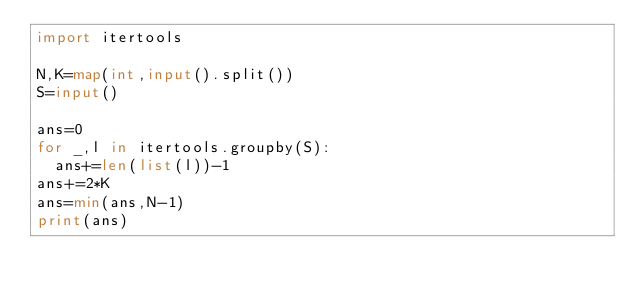Convert code to text. <code><loc_0><loc_0><loc_500><loc_500><_Python_>import itertools

N,K=map(int,input().split())
S=input()

ans=0
for _,l in itertools.groupby(S):
  ans+=len(list(l))-1
ans+=2*K
ans=min(ans,N-1)
print(ans)</code> 